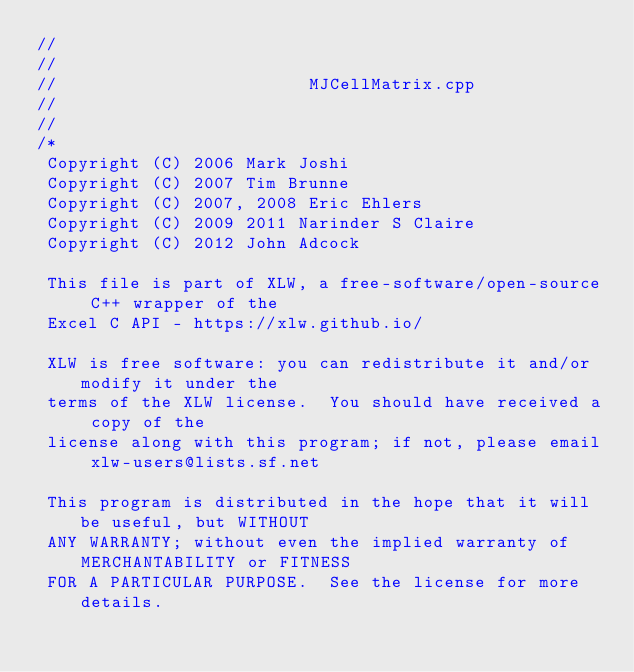Convert code to text. <code><loc_0><loc_0><loc_500><loc_500><_C++_>//
//
//                        MJCellMatrix.cpp
//
//
/*
 Copyright (C) 2006 Mark Joshi
 Copyright (C) 2007 Tim Brunne
 Copyright (C) 2007, 2008 Eric Ehlers
 Copyright (C) 2009 2011 Narinder S Claire
 Copyright (C) 2012 John Adcock

 This file is part of XLW, a free-software/open-source C++ wrapper of the
 Excel C API - https://xlw.github.io/

 XLW is free software: you can redistribute it and/or modify it under the
 terms of the XLW license.  You should have received a copy of the
 license along with this program; if not, please email xlw-users@lists.sf.net

 This program is distributed in the hope that it will be useful, but WITHOUT
 ANY WARRANTY; without even the implied warranty of MERCHANTABILITY or FITNESS
 FOR A PARTICULAR PURPOSE.  See the license for more details.</code> 